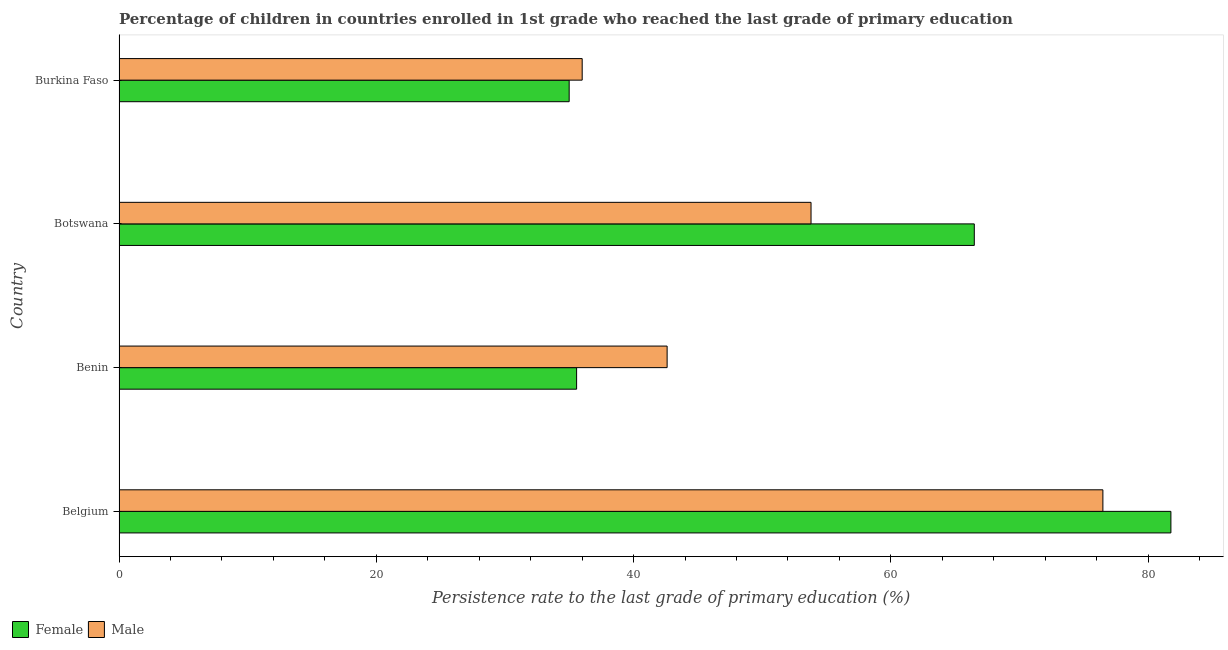Are the number of bars per tick equal to the number of legend labels?
Provide a succinct answer. Yes. How many bars are there on the 2nd tick from the bottom?
Keep it short and to the point. 2. What is the label of the 2nd group of bars from the top?
Provide a succinct answer. Botswana. What is the persistence rate of female students in Burkina Faso?
Provide a short and direct response. 34.99. Across all countries, what is the maximum persistence rate of female students?
Your response must be concise. 81.77. Across all countries, what is the minimum persistence rate of male students?
Your answer should be compact. 36. In which country was the persistence rate of male students minimum?
Make the answer very short. Burkina Faso. What is the total persistence rate of female students in the graph?
Offer a very short reply. 218.82. What is the difference between the persistence rate of male students in Belgium and that in Benin?
Your answer should be very brief. 33.88. What is the difference between the persistence rate of female students in Benin and the persistence rate of male students in Burkina Faso?
Keep it short and to the point. -0.43. What is the average persistence rate of male students per country?
Keep it short and to the point. 52.22. What is the difference between the persistence rate of female students and persistence rate of male students in Benin?
Offer a very short reply. -7.04. In how many countries, is the persistence rate of male students greater than 72 %?
Make the answer very short. 1. What is the ratio of the persistence rate of male students in Benin to that in Botswana?
Give a very brief answer. 0.79. Is the difference between the persistence rate of female students in Belgium and Botswana greater than the difference between the persistence rate of male students in Belgium and Botswana?
Keep it short and to the point. No. What is the difference between the highest and the second highest persistence rate of female students?
Ensure brevity in your answer.  15.28. What is the difference between the highest and the lowest persistence rate of female students?
Ensure brevity in your answer.  46.78. What does the 2nd bar from the bottom in Belgium represents?
Provide a succinct answer. Male. Does the graph contain any zero values?
Keep it short and to the point. No. How many legend labels are there?
Ensure brevity in your answer.  2. What is the title of the graph?
Your answer should be very brief. Percentage of children in countries enrolled in 1st grade who reached the last grade of primary education. Does "Urban" appear as one of the legend labels in the graph?
Provide a short and direct response. No. What is the label or title of the X-axis?
Give a very brief answer. Persistence rate to the last grade of primary education (%). What is the label or title of the Y-axis?
Your answer should be compact. Country. What is the Persistence rate to the last grade of primary education (%) of Female in Belgium?
Provide a short and direct response. 81.77. What is the Persistence rate to the last grade of primary education (%) of Male in Belgium?
Provide a succinct answer. 76.48. What is the Persistence rate to the last grade of primary education (%) in Female in Benin?
Your response must be concise. 35.57. What is the Persistence rate to the last grade of primary education (%) of Male in Benin?
Give a very brief answer. 42.61. What is the Persistence rate to the last grade of primary education (%) of Female in Botswana?
Make the answer very short. 66.49. What is the Persistence rate to the last grade of primary education (%) in Male in Botswana?
Provide a short and direct response. 53.79. What is the Persistence rate to the last grade of primary education (%) of Female in Burkina Faso?
Make the answer very short. 34.99. What is the Persistence rate to the last grade of primary education (%) of Male in Burkina Faso?
Provide a short and direct response. 36. Across all countries, what is the maximum Persistence rate to the last grade of primary education (%) of Female?
Your answer should be compact. 81.77. Across all countries, what is the maximum Persistence rate to the last grade of primary education (%) of Male?
Give a very brief answer. 76.48. Across all countries, what is the minimum Persistence rate to the last grade of primary education (%) in Female?
Make the answer very short. 34.99. Across all countries, what is the minimum Persistence rate to the last grade of primary education (%) in Male?
Ensure brevity in your answer.  36. What is the total Persistence rate to the last grade of primary education (%) in Female in the graph?
Your response must be concise. 218.82. What is the total Persistence rate to the last grade of primary education (%) in Male in the graph?
Ensure brevity in your answer.  208.89. What is the difference between the Persistence rate to the last grade of primary education (%) of Female in Belgium and that in Benin?
Offer a terse response. 46.2. What is the difference between the Persistence rate to the last grade of primary education (%) of Male in Belgium and that in Benin?
Your answer should be compact. 33.87. What is the difference between the Persistence rate to the last grade of primary education (%) of Female in Belgium and that in Botswana?
Make the answer very short. 15.28. What is the difference between the Persistence rate to the last grade of primary education (%) in Male in Belgium and that in Botswana?
Provide a succinct answer. 22.69. What is the difference between the Persistence rate to the last grade of primary education (%) of Female in Belgium and that in Burkina Faso?
Offer a terse response. 46.78. What is the difference between the Persistence rate to the last grade of primary education (%) of Male in Belgium and that in Burkina Faso?
Give a very brief answer. 40.48. What is the difference between the Persistence rate to the last grade of primary education (%) in Female in Benin and that in Botswana?
Offer a terse response. -30.92. What is the difference between the Persistence rate to the last grade of primary education (%) in Male in Benin and that in Botswana?
Give a very brief answer. -11.19. What is the difference between the Persistence rate to the last grade of primary education (%) in Female in Benin and that in Burkina Faso?
Offer a very short reply. 0.58. What is the difference between the Persistence rate to the last grade of primary education (%) of Male in Benin and that in Burkina Faso?
Your response must be concise. 6.6. What is the difference between the Persistence rate to the last grade of primary education (%) of Female in Botswana and that in Burkina Faso?
Offer a very short reply. 31.49. What is the difference between the Persistence rate to the last grade of primary education (%) of Male in Botswana and that in Burkina Faso?
Keep it short and to the point. 17.79. What is the difference between the Persistence rate to the last grade of primary education (%) in Female in Belgium and the Persistence rate to the last grade of primary education (%) in Male in Benin?
Provide a succinct answer. 39.16. What is the difference between the Persistence rate to the last grade of primary education (%) in Female in Belgium and the Persistence rate to the last grade of primary education (%) in Male in Botswana?
Your answer should be very brief. 27.98. What is the difference between the Persistence rate to the last grade of primary education (%) in Female in Belgium and the Persistence rate to the last grade of primary education (%) in Male in Burkina Faso?
Keep it short and to the point. 45.77. What is the difference between the Persistence rate to the last grade of primary education (%) of Female in Benin and the Persistence rate to the last grade of primary education (%) of Male in Botswana?
Your answer should be compact. -18.22. What is the difference between the Persistence rate to the last grade of primary education (%) in Female in Benin and the Persistence rate to the last grade of primary education (%) in Male in Burkina Faso?
Offer a very short reply. -0.43. What is the difference between the Persistence rate to the last grade of primary education (%) of Female in Botswana and the Persistence rate to the last grade of primary education (%) of Male in Burkina Faso?
Make the answer very short. 30.48. What is the average Persistence rate to the last grade of primary education (%) of Female per country?
Keep it short and to the point. 54.7. What is the average Persistence rate to the last grade of primary education (%) of Male per country?
Ensure brevity in your answer.  52.22. What is the difference between the Persistence rate to the last grade of primary education (%) of Female and Persistence rate to the last grade of primary education (%) of Male in Belgium?
Your answer should be compact. 5.29. What is the difference between the Persistence rate to the last grade of primary education (%) of Female and Persistence rate to the last grade of primary education (%) of Male in Benin?
Your answer should be compact. -7.04. What is the difference between the Persistence rate to the last grade of primary education (%) in Female and Persistence rate to the last grade of primary education (%) in Male in Botswana?
Offer a very short reply. 12.69. What is the difference between the Persistence rate to the last grade of primary education (%) in Female and Persistence rate to the last grade of primary education (%) in Male in Burkina Faso?
Your response must be concise. -1.01. What is the ratio of the Persistence rate to the last grade of primary education (%) of Female in Belgium to that in Benin?
Provide a succinct answer. 2.3. What is the ratio of the Persistence rate to the last grade of primary education (%) of Male in Belgium to that in Benin?
Provide a succinct answer. 1.79. What is the ratio of the Persistence rate to the last grade of primary education (%) of Female in Belgium to that in Botswana?
Provide a succinct answer. 1.23. What is the ratio of the Persistence rate to the last grade of primary education (%) of Male in Belgium to that in Botswana?
Your response must be concise. 1.42. What is the ratio of the Persistence rate to the last grade of primary education (%) in Female in Belgium to that in Burkina Faso?
Provide a short and direct response. 2.34. What is the ratio of the Persistence rate to the last grade of primary education (%) of Male in Belgium to that in Burkina Faso?
Provide a succinct answer. 2.12. What is the ratio of the Persistence rate to the last grade of primary education (%) of Female in Benin to that in Botswana?
Offer a very short reply. 0.54. What is the ratio of the Persistence rate to the last grade of primary education (%) in Male in Benin to that in Botswana?
Your answer should be very brief. 0.79. What is the ratio of the Persistence rate to the last grade of primary education (%) of Female in Benin to that in Burkina Faso?
Make the answer very short. 1.02. What is the ratio of the Persistence rate to the last grade of primary education (%) in Male in Benin to that in Burkina Faso?
Keep it short and to the point. 1.18. What is the ratio of the Persistence rate to the last grade of primary education (%) in Male in Botswana to that in Burkina Faso?
Offer a very short reply. 1.49. What is the difference between the highest and the second highest Persistence rate to the last grade of primary education (%) in Female?
Offer a very short reply. 15.28. What is the difference between the highest and the second highest Persistence rate to the last grade of primary education (%) of Male?
Give a very brief answer. 22.69. What is the difference between the highest and the lowest Persistence rate to the last grade of primary education (%) in Female?
Make the answer very short. 46.78. What is the difference between the highest and the lowest Persistence rate to the last grade of primary education (%) in Male?
Keep it short and to the point. 40.48. 